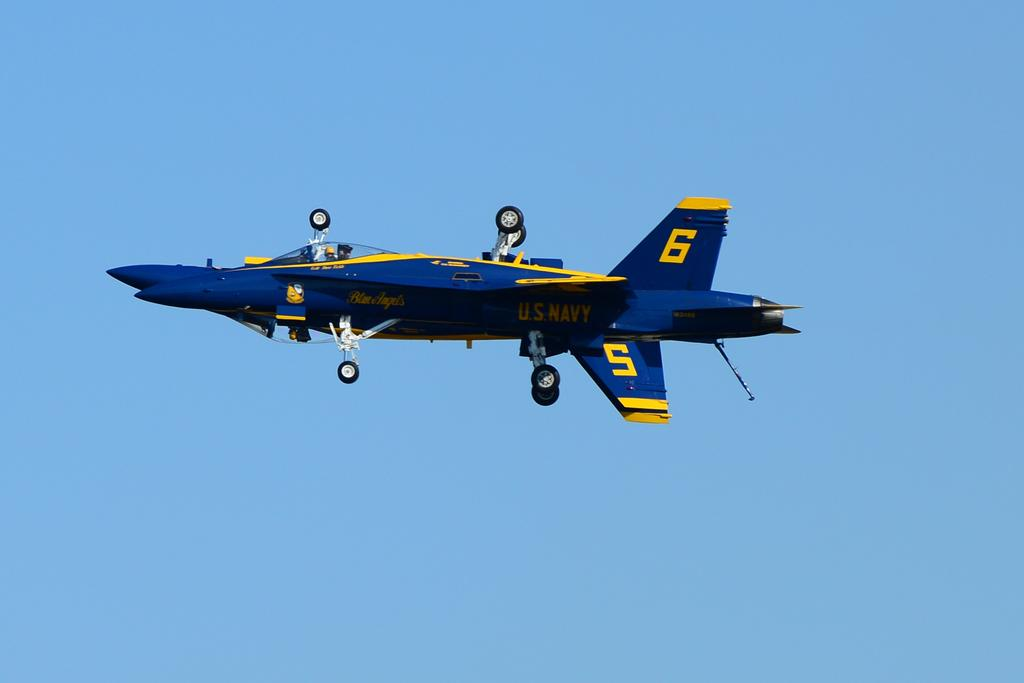<image>
Create a compact narrative representing the image presented. a plane that has the number 6 and 5 on the side of it 